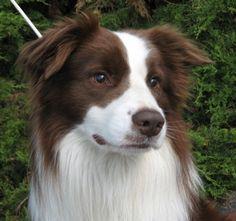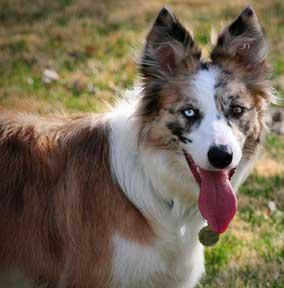The first image is the image on the left, the second image is the image on the right. Examine the images to the left and right. Is the description "The lefthand image shows a non-standing, frontward-facing brown and white dog with non-erect erects." accurate? Answer yes or no. Yes. 